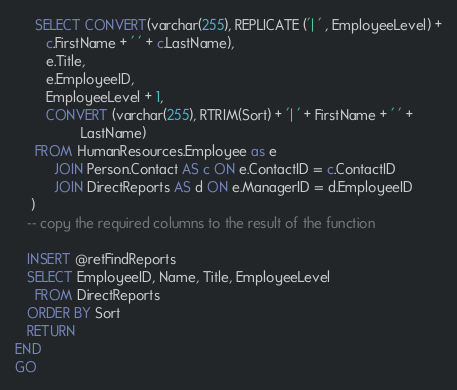<code> <loc_0><loc_0><loc_500><loc_500><_SQL_>     SELECT CONVERT(varchar(255), REPLICATE ('| ' , EmployeeLevel) +
        c.FirstName + ' ' + c.LastName),
        e.Title,
        e.EmployeeID,
        EmployeeLevel + 1,
        CONVERT (varchar(255), RTRIM(Sort) + '| ' + FirstName + ' ' + 
                 LastName)
     FROM HumanResources.Employee as e
          JOIN Person.Contact AS c ON e.ContactID = c.ContactID
          JOIN DirectReports AS d ON e.ManagerID = d.EmployeeID
    )
   -- copy the required columns to the result of the function 

   INSERT @retFindReports
   SELECT EmployeeID, Name, Title, EmployeeLevel
     FROM DirectReports 
   ORDER BY Sort
   RETURN
END
GO


</code> 